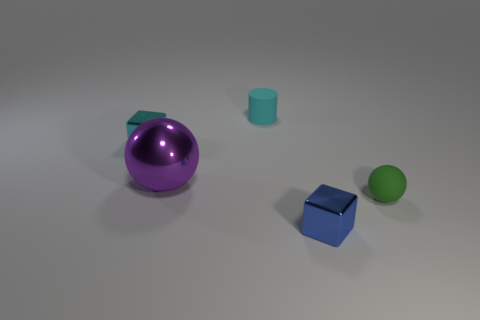What is the size of the thing that is made of the same material as the cylinder?
Give a very brief answer. Small. There is a tiny rubber object that is on the left side of the small sphere; does it have the same shape as the rubber object that is to the right of the blue cube?
Offer a very short reply. No. What is the color of the ball that is made of the same material as the tiny cyan cylinder?
Your response must be concise. Green. There is a sphere to the right of the tiny blue block; is its size the same as the matte object that is left of the green thing?
Provide a succinct answer. Yes. There is a small thing that is on the right side of the purple shiny ball and behind the purple thing; what shape is it?
Offer a terse response. Cylinder. Is there a tiny object that has the same material as the small cylinder?
Offer a terse response. Yes. What is the material of the tiny thing that is the same color as the small cylinder?
Offer a terse response. Metal. Is the material of the tiny block that is on the right side of the big purple metallic object the same as the tiny cube that is left of the small cyan matte thing?
Make the answer very short. Yes. Is the number of metallic cubes greater than the number of small green matte objects?
Keep it short and to the point. Yes. What is the color of the sphere that is left of the small object in front of the small rubber thing that is in front of the small cyan matte cylinder?
Provide a short and direct response. Purple. 